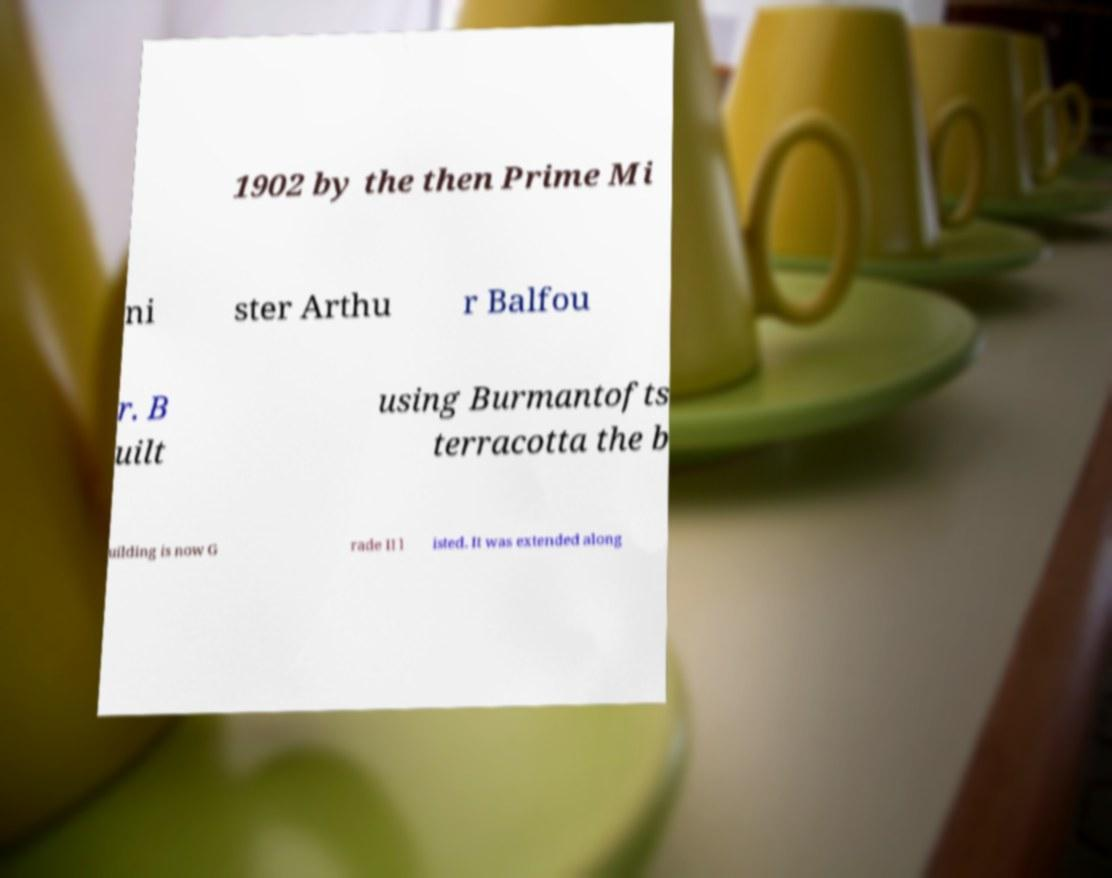Could you assist in decoding the text presented in this image and type it out clearly? 1902 by the then Prime Mi ni ster Arthu r Balfou r. B uilt using Burmantofts terracotta the b uilding is now G rade II l isted. It was extended along 